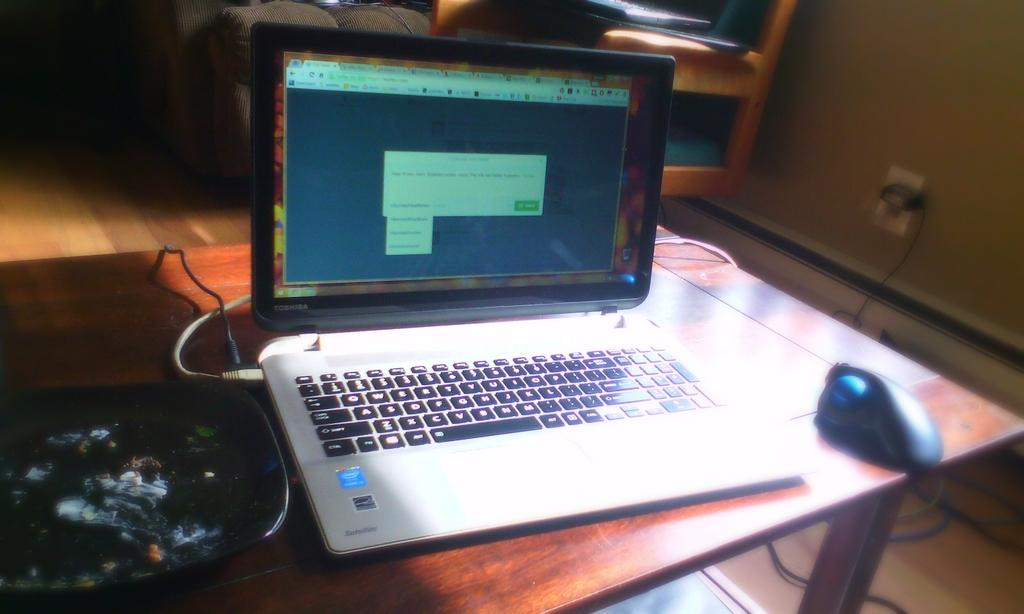What electronic device is visible in the image? There is a laptop in the image. What accessory is present for the laptop? There is a mouse in the image. Where are the laptop and mouse located? Both the laptop and the mouse are on a table. What type of action is taking place in the town depicted in the image? There is no town or action present in the image; it only features a laptop and a mouse on a table. What is the zinc content of the laptop in the image? The image does not provide information about the zinc content of the laptop, nor is there any mention of zinc in the image. 